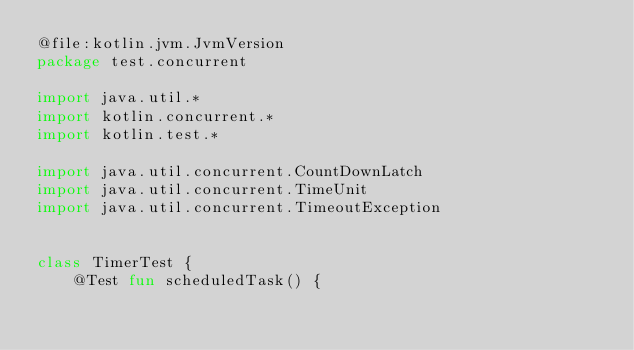Convert code to text. <code><loc_0><loc_0><loc_500><loc_500><_Kotlin_>@file:kotlin.jvm.JvmVersion
package test.concurrent

import java.util.*
import kotlin.concurrent.*
import kotlin.test.*

import java.util.concurrent.CountDownLatch
import java.util.concurrent.TimeUnit
import java.util.concurrent.TimeoutException


class TimerTest {
    @Test fun scheduledTask() {</code> 